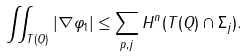Convert formula to latex. <formula><loc_0><loc_0><loc_500><loc_500>\iint _ { T ( Q ) } | \nabla \varphi _ { 1 } | \leq \sum _ { p , j } H ^ { n } ( T ( Q ) \cap \Sigma _ { j } ) .</formula> 